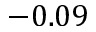<formula> <loc_0><loc_0><loc_500><loc_500>- 0 . 0 9</formula> 